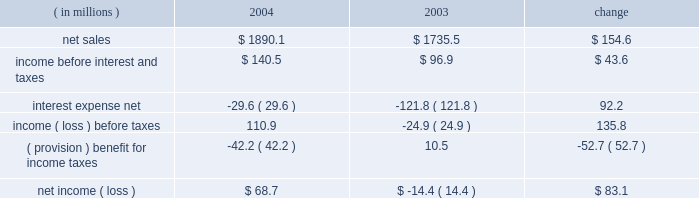Instruments at fair value and to recognize the effective and ineffective portions of the cash flow hedges .
( 2 ) for the year ended december 31 , 2000 , earnings available to common stockholders includes reductions of $ 2371 of preferred stock dividends and $ 16266 for the redemption of pca 2019s 123 20448% ( 20448 % ) preferred stock .
( 3 ) on october 13 , 2003 , pca announced its intention to begin paying a quarterly cash dividend of $ 0.15 per share , or $ 0.60 per share annually , on its common stock .
The first quarterly dividend of $ 0.15 per share was paid on january 15 , 2004 to shareholders of record as of december 15 , 2003 .
Pca did not declare any dividends on its common stock in 2000 - 2002 .
( 4 ) total long-term obligations include long-term debt , short-term debt and the current maturities of long-term debt .
Item 7 .
Management 2019s discussion and analysis of financial condition and results of operations the following discussion of historical results of operations and financial condition should be read in conjunction with the audited financial statements and the notes thereto which appear elsewhere in this report .
Overview on april 12 , 1999 , pca acquired the containerboard and corrugated products business of pactiv corporation ( the 201cgroup 201d ) , formerly known as tenneco packaging inc. , a wholly owned subsidiary of tenneco , inc .
The group operated prior to april 12 , 1999 as a division of pactiv , and not as a separate , stand-alone entity .
From its formation in january 1999 and through the closing of the acquisition on april 12 , 1999 , pca did not have any significant operations .
The april 12 , 1999 acquisition was accounted for using historical values for the contributed assets .
Purchase accounting was not applied because , under the applicable accounting guidance , a change of control was deemed not to have occurred as a result of the participating veto rights held by pactiv after the closing of the transactions under the terms of the stockholders agreement entered into in connection with the transactions .
Results of operations year ended december 31 , 2004 compared to year ended december 31 , 2003 the historical results of operations of pca for the years ended december , 31 2004 and 2003 are set forth the below : for the year ended december 31 , ( in millions ) 2004 2003 change .

By what percent did net sales increase from 2003 to 2004? 
Computations: (154.6 / 1735.5)
Answer: 0.08908. 